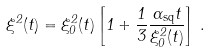<formula> <loc_0><loc_0><loc_500><loc_500>\xi ^ { 2 } ( t ) = \xi ^ { 2 } _ { 0 } ( t ) \left [ 1 + \frac { 1 } { 3 } \frac { \Gamma _ { \text {sq} } t } { \xi ^ { 2 } _ { 0 } ( t ) } \right ] \, .</formula> 